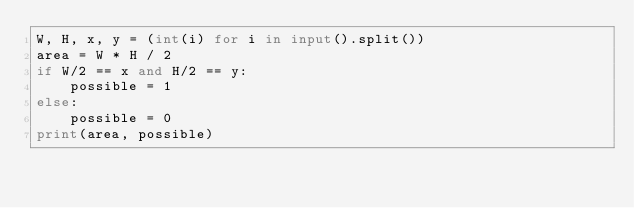Convert code to text. <code><loc_0><loc_0><loc_500><loc_500><_Python_>W, H, x, y = (int(i) for i in input().split())
area = W * H / 2
if W/2 == x and H/2 == y:
    possible = 1
else:
    possible = 0
print(area, possible)</code> 